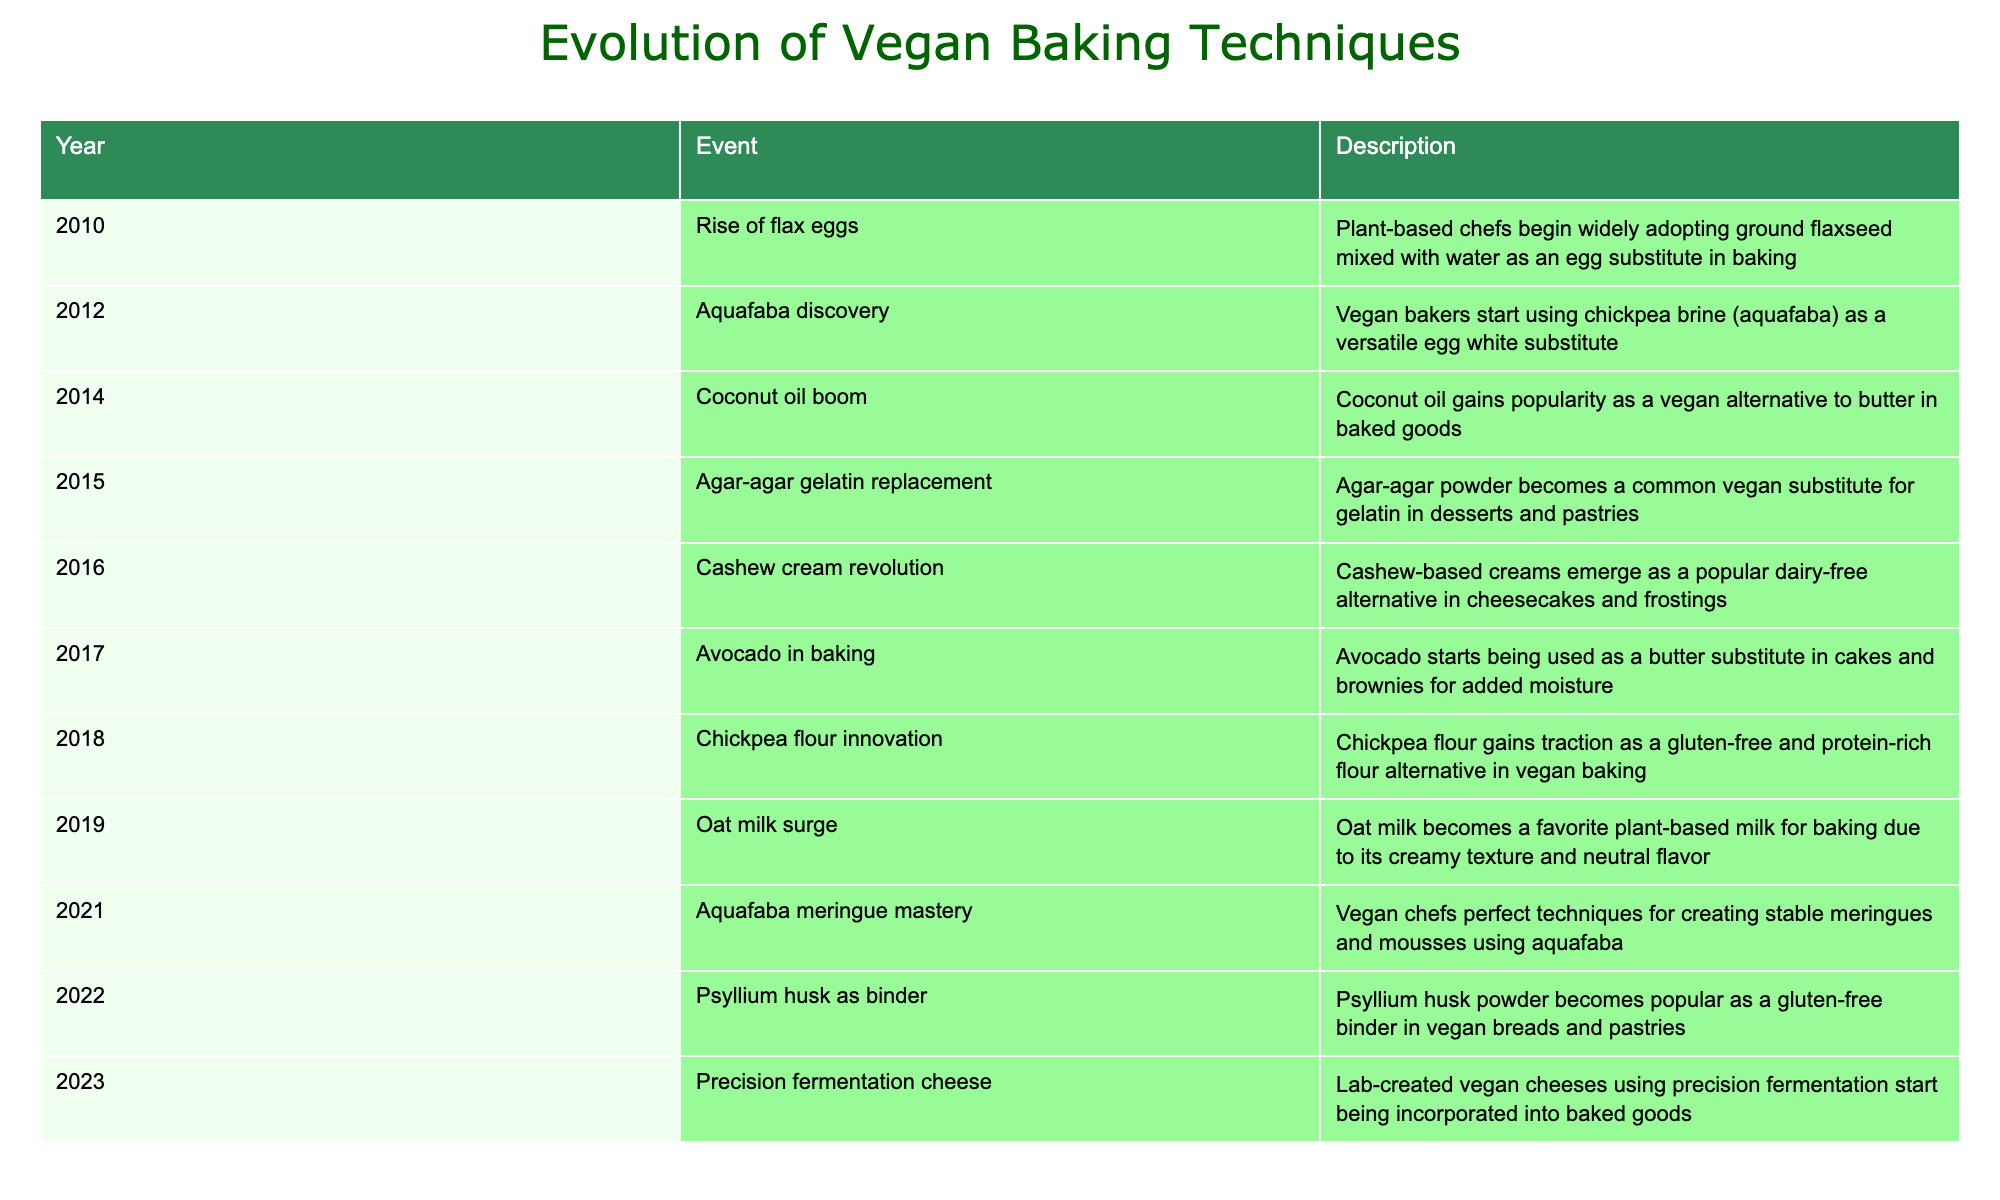What event marked the rise of flax eggs in 2010? In 2010, the introduction of ground flaxseed mixed with water as an egg substitute created a significant trend, widely adopted by plant-based chefs for baking.
Answer: Rise of flax eggs Which plant-based milk surged in popularity for baking in 2019? The table indicates that oat milk became a favorite for baking in 2019 due to its creamy texture and neutral flavor.
Answer: Oat milk True or False: Avocado started being used as a butter substitute in cakes and brownies in 2017. The table confirms that in 2017, avocado began to be used as a butter substitute in baking, making this statement true.
Answer: True How many events related to vegan baking techniques happened between 2010 and 2022? By counting the events listed from 2010 to 2022, there are a total of 8 significant events mentioned in the table.
Answer: 8 What is the significance of aquafaba discovery in 2012? In 2012, the discovery of aquafaba (chickpea brine) was significant as it became a versatile egg white substitute, changing the baking landscape for vegan recipes.
Answer: Versatile egg white substitute True or False: Agar-agar was used as a common vegan substitute for milk in 2015. The table specifies that agar-agar became a common substitute for gelatin, not milk, in 2015, so the statement is false.
Answer: False What were the last two innovations listed in the table for vegan baking techniques? The last two innovations noted are "Psyllium husk as binder" in 2022 and "Precision fermentation cheese" in 2023, which highlight recent advancements in vegan baking.
Answer: Psyllium husk as binder, Precision fermentation cheese Which baking technique had its mastery perfected in 2021? The table shows that in 2021, vegan chefs perfected techniques for creating stable meringues and mousses using aquafaba.
Answer: Aquafaba meringue mastery How many years passed between the introduction of coconut oil as a vegan alternative and the revolution of cashew cream? Coconut oil was introduced in 2014 and cashew cream in 2016. The difference is 2 years.
Answer: 2 years 